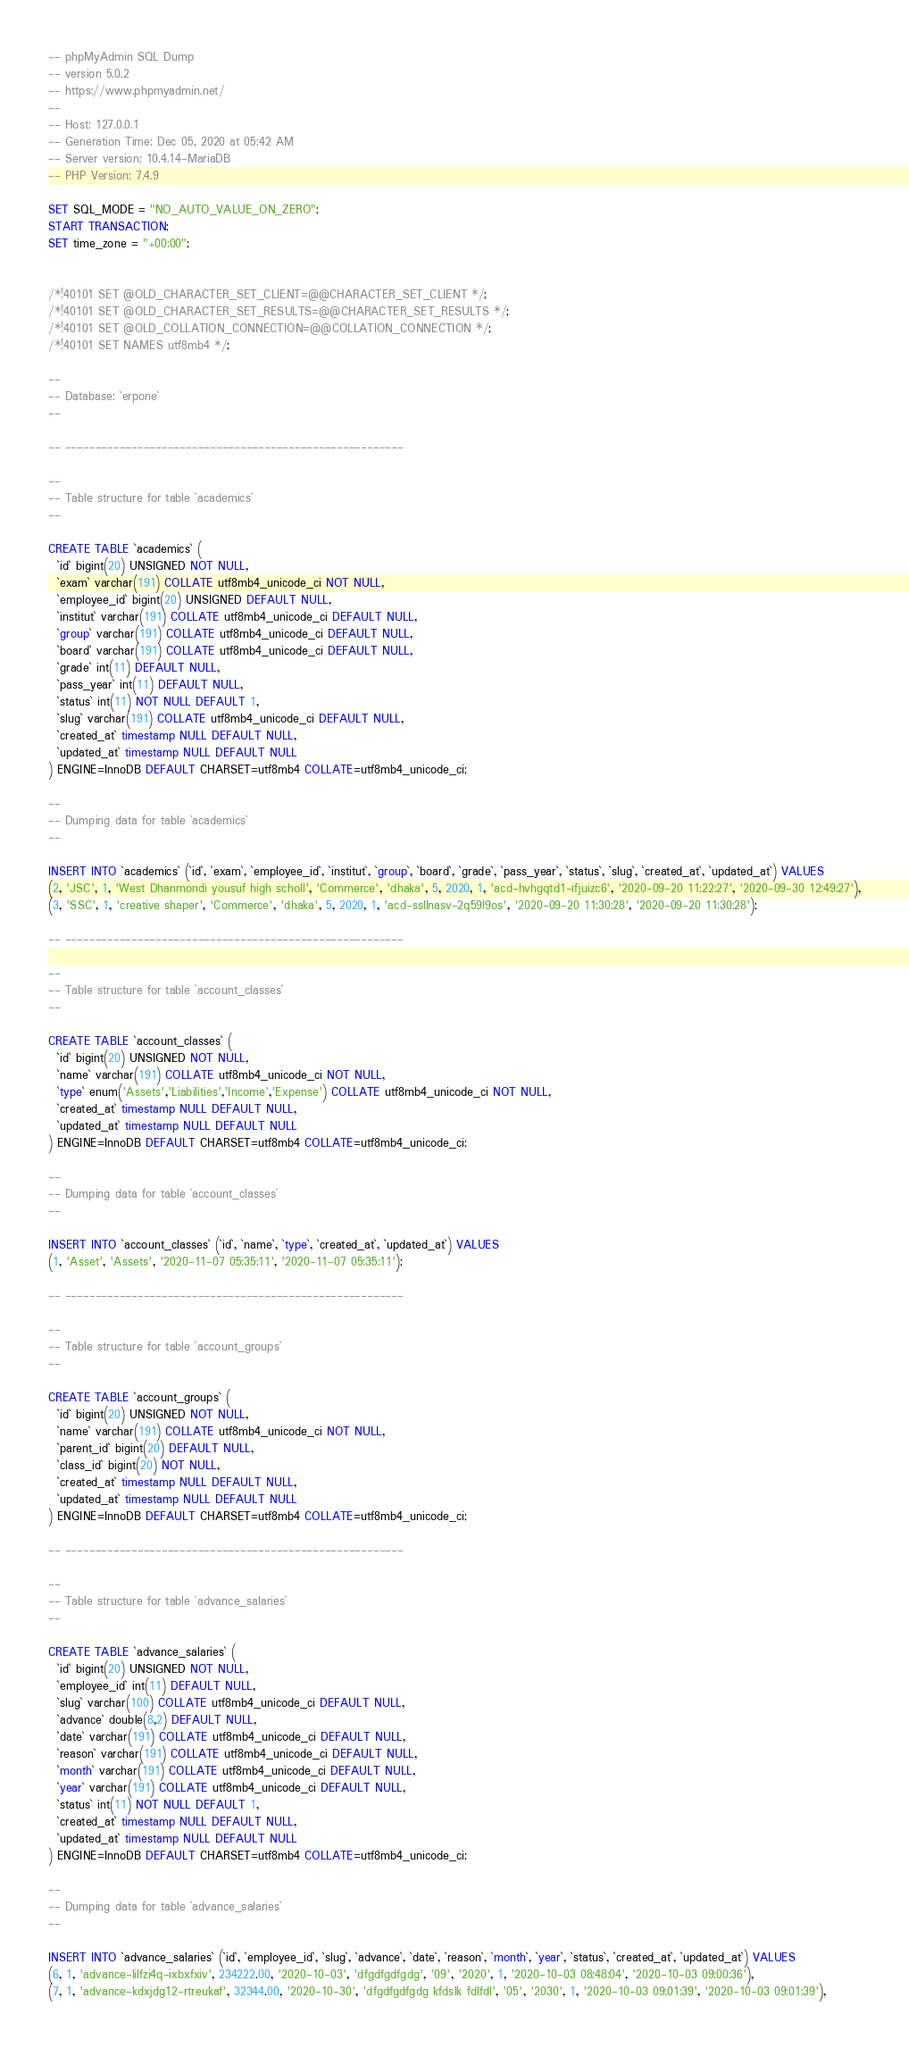Convert code to text. <code><loc_0><loc_0><loc_500><loc_500><_SQL_>-- phpMyAdmin SQL Dump
-- version 5.0.2
-- https://www.phpmyadmin.net/
--
-- Host: 127.0.0.1
-- Generation Time: Dec 05, 2020 at 05:42 AM
-- Server version: 10.4.14-MariaDB
-- PHP Version: 7.4.9

SET SQL_MODE = "NO_AUTO_VALUE_ON_ZERO";
START TRANSACTION;
SET time_zone = "+00:00";


/*!40101 SET @OLD_CHARACTER_SET_CLIENT=@@CHARACTER_SET_CLIENT */;
/*!40101 SET @OLD_CHARACTER_SET_RESULTS=@@CHARACTER_SET_RESULTS */;
/*!40101 SET @OLD_COLLATION_CONNECTION=@@COLLATION_CONNECTION */;
/*!40101 SET NAMES utf8mb4 */;

--
-- Database: `erpone`
--

-- --------------------------------------------------------

--
-- Table structure for table `academics`
--

CREATE TABLE `academics` (
  `id` bigint(20) UNSIGNED NOT NULL,
  `exam` varchar(191) COLLATE utf8mb4_unicode_ci NOT NULL,
  `employee_id` bigint(20) UNSIGNED DEFAULT NULL,
  `institut` varchar(191) COLLATE utf8mb4_unicode_ci DEFAULT NULL,
  `group` varchar(191) COLLATE utf8mb4_unicode_ci DEFAULT NULL,
  `board` varchar(191) COLLATE utf8mb4_unicode_ci DEFAULT NULL,
  `grade` int(11) DEFAULT NULL,
  `pass_year` int(11) DEFAULT NULL,
  `status` int(11) NOT NULL DEFAULT 1,
  `slug` varchar(191) COLLATE utf8mb4_unicode_ci DEFAULT NULL,
  `created_at` timestamp NULL DEFAULT NULL,
  `updated_at` timestamp NULL DEFAULT NULL
) ENGINE=InnoDB DEFAULT CHARSET=utf8mb4 COLLATE=utf8mb4_unicode_ci;

--
-- Dumping data for table `academics`
--

INSERT INTO `academics` (`id`, `exam`, `employee_id`, `institut`, `group`, `board`, `grade`, `pass_year`, `status`, `slug`, `created_at`, `updated_at`) VALUES
(2, 'JSC', 1, 'West Dhanmondi yousuf high scholl', 'Commerce', 'dhaka', 5, 2020, 1, 'acd-hvhgqtd1-ifjuizc6', '2020-09-20 11:22:27', '2020-09-30 12:49:27'),
(3, 'SSC', 1, 'creative shaper', 'Commerce', 'dhaka', 5, 2020, 1, 'acd-ssllnasv-2q59l9os', '2020-09-20 11:30:28', '2020-09-20 11:30:28');

-- --------------------------------------------------------

--
-- Table structure for table `account_classes`
--

CREATE TABLE `account_classes` (
  `id` bigint(20) UNSIGNED NOT NULL,
  `name` varchar(191) COLLATE utf8mb4_unicode_ci NOT NULL,
  `type` enum('Assets','Liabilities','Income','Expense') COLLATE utf8mb4_unicode_ci NOT NULL,
  `created_at` timestamp NULL DEFAULT NULL,
  `updated_at` timestamp NULL DEFAULT NULL
) ENGINE=InnoDB DEFAULT CHARSET=utf8mb4 COLLATE=utf8mb4_unicode_ci;

--
-- Dumping data for table `account_classes`
--

INSERT INTO `account_classes` (`id`, `name`, `type`, `created_at`, `updated_at`) VALUES
(1, 'Asset', 'Assets', '2020-11-07 05:35:11', '2020-11-07 05:35:11');

-- --------------------------------------------------------

--
-- Table structure for table `account_groups`
--

CREATE TABLE `account_groups` (
  `id` bigint(20) UNSIGNED NOT NULL,
  `name` varchar(191) COLLATE utf8mb4_unicode_ci NOT NULL,
  `parent_id` bigint(20) DEFAULT NULL,
  `class_id` bigint(20) NOT NULL,
  `created_at` timestamp NULL DEFAULT NULL,
  `updated_at` timestamp NULL DEFAULT NULL
) ENGINE=InnoDB DEFAULT CHARSET=utf8mb4 COLLATE=utf8mb4_unicode_ci;

-- --------------------------------------------------------

--
-- Table structure for table `advance_salaries`
--

CREATE TABLE `advance_salaries` (
  `id` bigint(20) UNSIGNED NOT NULL,
  `employee_id` int(11) DEFAULT NULL,
  `slug` varchar(100) COLLATE utf8mb4_unicode_ci DEFAULT NULL,
  `advance` double(8,2) DEFAULT NULL,
  `date` varchar(191) COLLATE utf8mb4_unicode_ci DEFAULT NULL,
  `reason` varchar(191) COLLATE utf8mb4_unicode_ci DEFAULT NULL,
  `month` varchar(191) COLLATE utf8mb4_unicode_ci DEFAULT NULL,
  `year` varchar(191) COLLATE utf8mb4_unicode_ci DEFAULT NULL,
  `status` int(11) NOT NULL DEFAULT 1,
  `created_at` timestamp NULL DEFAULT NULL,
  `updated_at` timestamp NULL DEFAULT NULL
) ENGINE=InnoDB DEFAULT CHARSET=utf8mb4 COLLATE=utf8mb4_unicode_ci;

--
-- Dumping data for table `advance_salaries`
--

INSERT INTO `advance_salaries` (`id`, `employee_id`, `slug`, `advance`, `date`, `reason`, `month`, `year`, `status`, `created_at`, `updated_at`) VALUES
(6, 1, 'advance-lilfzi4q-ixbxfxiv', 234222.00, '2020-10-03', 'dfgdfgdfgdg', '09', '2020', 1, '2020-10-03 08:48:04', '2020-10-03 09:00:36'),
(7, 1, 'advance-kdxjdg12-rtreukaf', 32344.00, '2020-10-30', 'dfgdfgdfgdg kfdslk fdlfdl', '05', '2030', 1, '2020-10-03 09:01:39', '2020-10-03 09:01:39'),</code> 